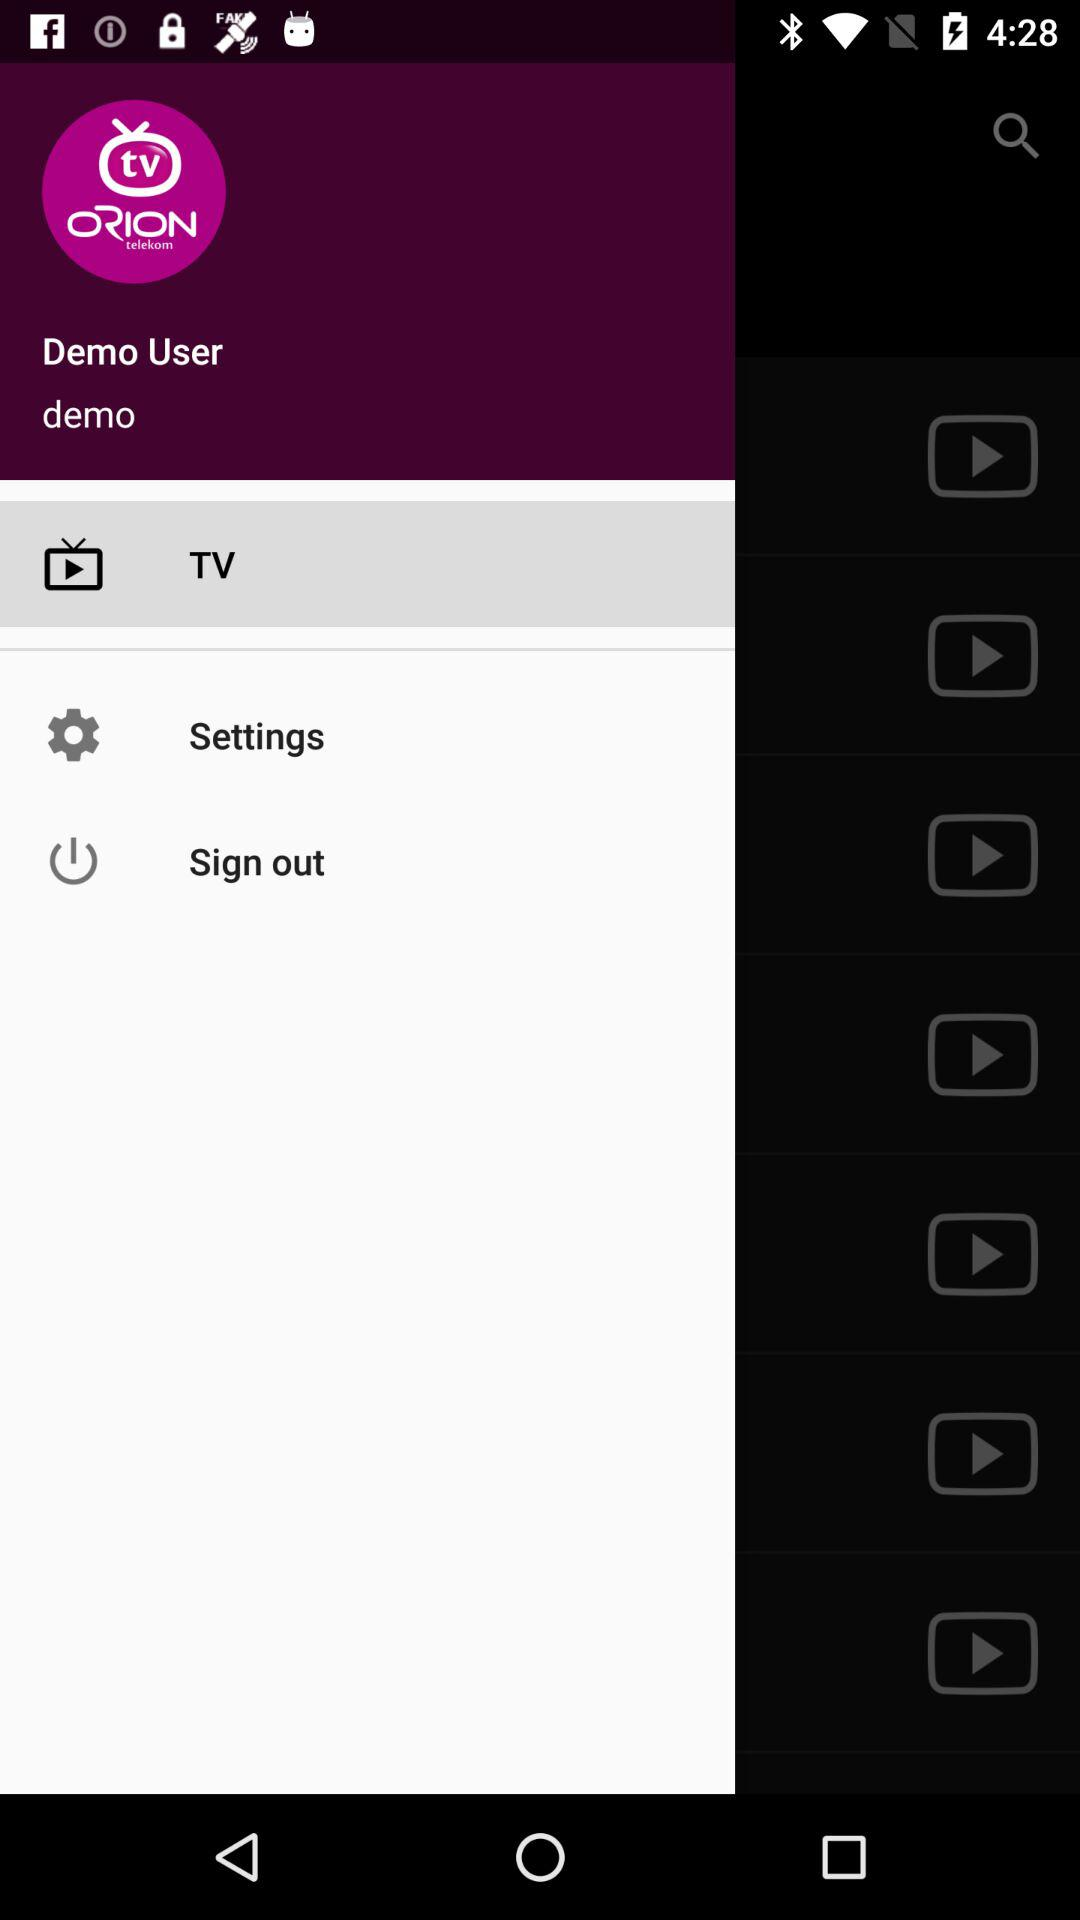What's the username? The username is "demo". 